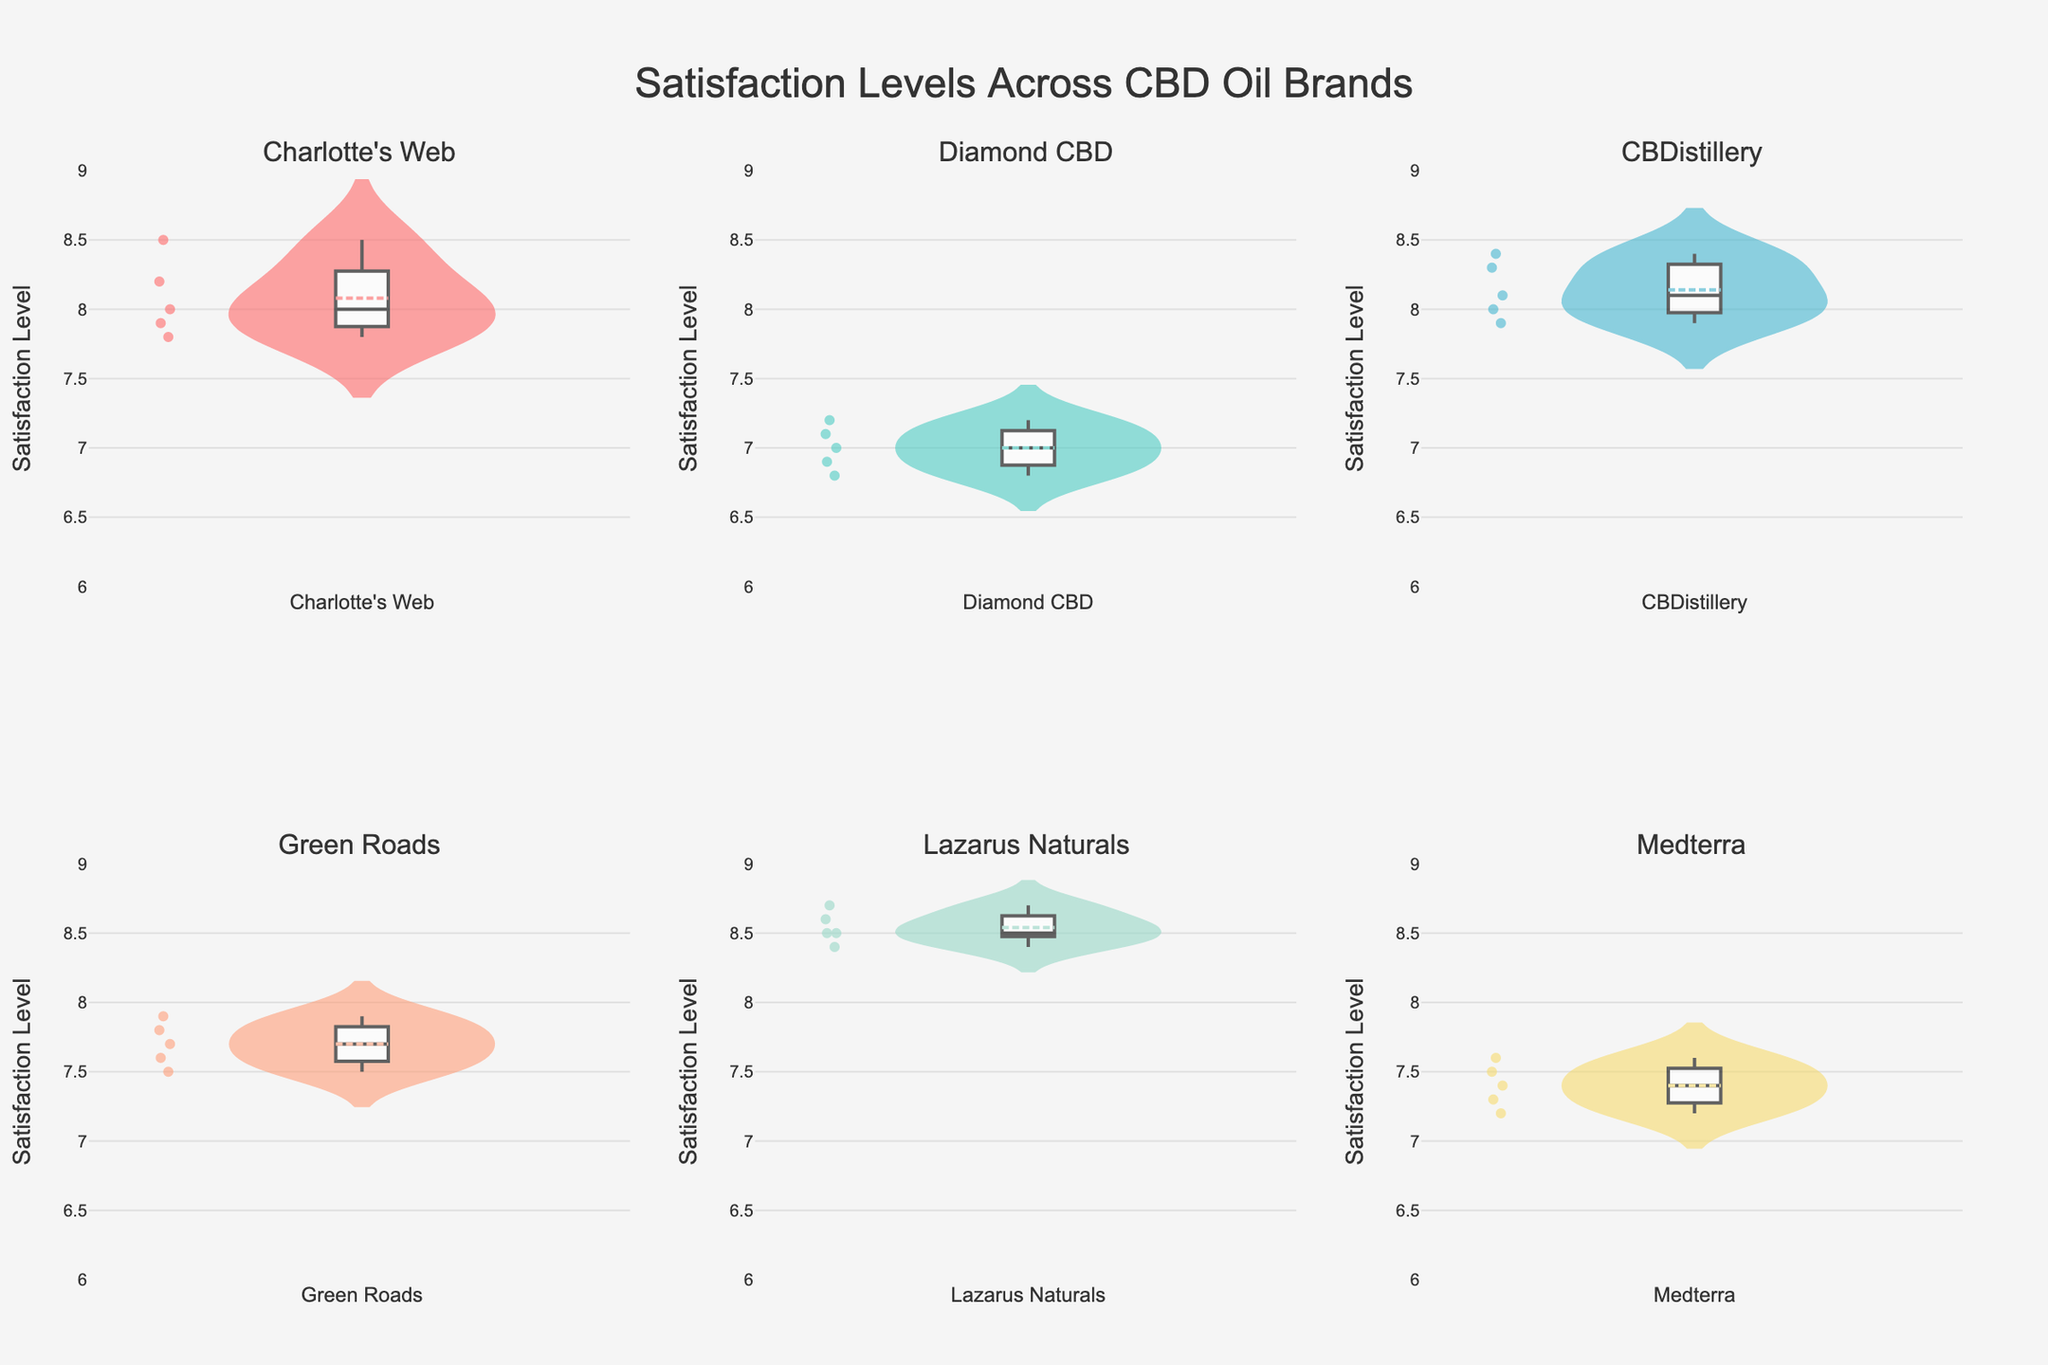What is the median satisfaction level for Charlotte's Web? The median is the middle value when the data points are ordered from lowest to highest. The satisfaction levels for Charlotte's Web are 7.8, 7.9, 8.0, 8.2, and 8.5. The median is the value at the third position, which is 8.0.
Answer: 8.0 Which brand has the highest average satisfaction level? To find the average satisfaction level for each brand, sum the satisfaction levels and divide by the number of data points. After doing so, Lazarus Naturals has the highest average (8.54).
Answer: Lazarus Naturals How do the satisfaction levels of Diamond CBD and Medterra compare? To compare the satisfaction levels, we can look at the distribution and overall average of each brand. Generally, Diamond CBD's satisfaction levels are lower (around 6.8 to 7.2) compared to Medterra's (around 7.2 to 7.6).
Answer: Medterra is higher What is the range of satisfaction levels for CBDistillery? The range is the difference between the highest and lowest values. For CBDistillery, the highest satisfaction level is 8.4, and the lowest is 7.9. The range is 8.4 - 7.9 = 0.5.
Answer: 0.5 Which brand's satisfaction levels have the smallest spread? The spread can be determined by looking at the range or the interquartile range. Lazarus Naturals' satisfaction levels are very close to each other, with values like 8.5, 8.7, 8.4, and 8.6. This small spread indicates lesser variability.
Answer: Lazarus Naturals Are there any brands that have a similar satisfaction level distribution? If so, which ones? By visually inspecting the distribution plots, Charlotte's Web and CBDistillery have similar distributions with closely clustered satisfaction levels around 8.0 to 8.5.
Answer: Charlotte's Web and CBDistillery What color represents satisfaction levels of Green Roads? Each brand is represented by a unique color in the plot. Green Roads is represented by the fourth color in the list, which can be seen as salmon (light orange).
Answer: Salmon/light orange Does any brand have an outlier in its satisfaction levels? Outliers can be identified by points that fall significantly outside the range of the rest of their distribution. None of the brands exhibit significant outliers as most values are consistently within expected ranges.
Answer: No significant outliers What is the mean satisfaction level for Medterra? The mean is calculated by summing the values and dividing by the number of values. For Medterra's satisfaction levels (7.4, 7.2, 7.6, 7.5, 7.3), the mean is (7.4 + 7.2 + 7.6 + 7.5 + 7.3) / 5 = 7.4.
Answer: 7.4 